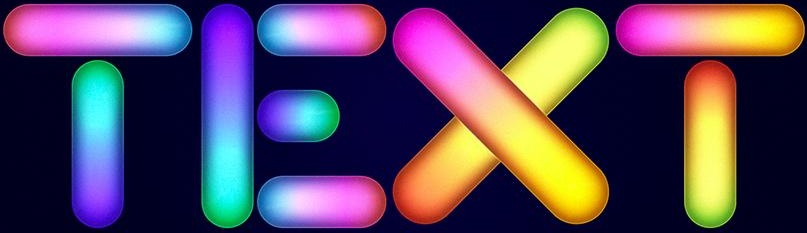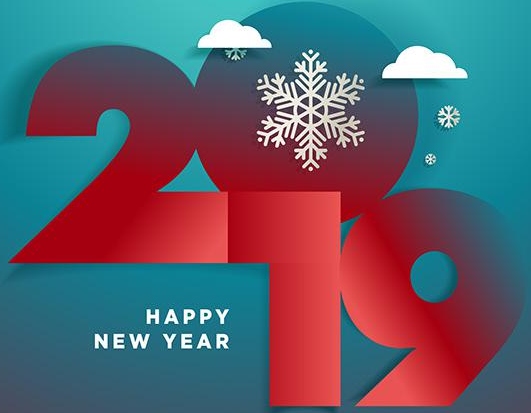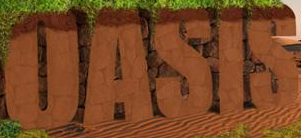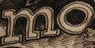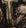What text is displayed in these images sequentially, separated by a semicolon? TEXT; 2019; OASIS; mo; # 